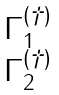<formula> <loc_0><loc_0><loc_500><loc_500>\begin{matrix} \Gamma ^ { ( \dagger ) } _ { 1 } \\ \Gamma ^ { ( \dagger ) } _ { 2 } \end{matrix}</formula> 